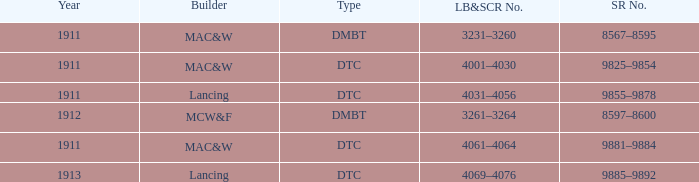Name the LB&SCR number that has SR number of 8597–8600 3261–3264. 